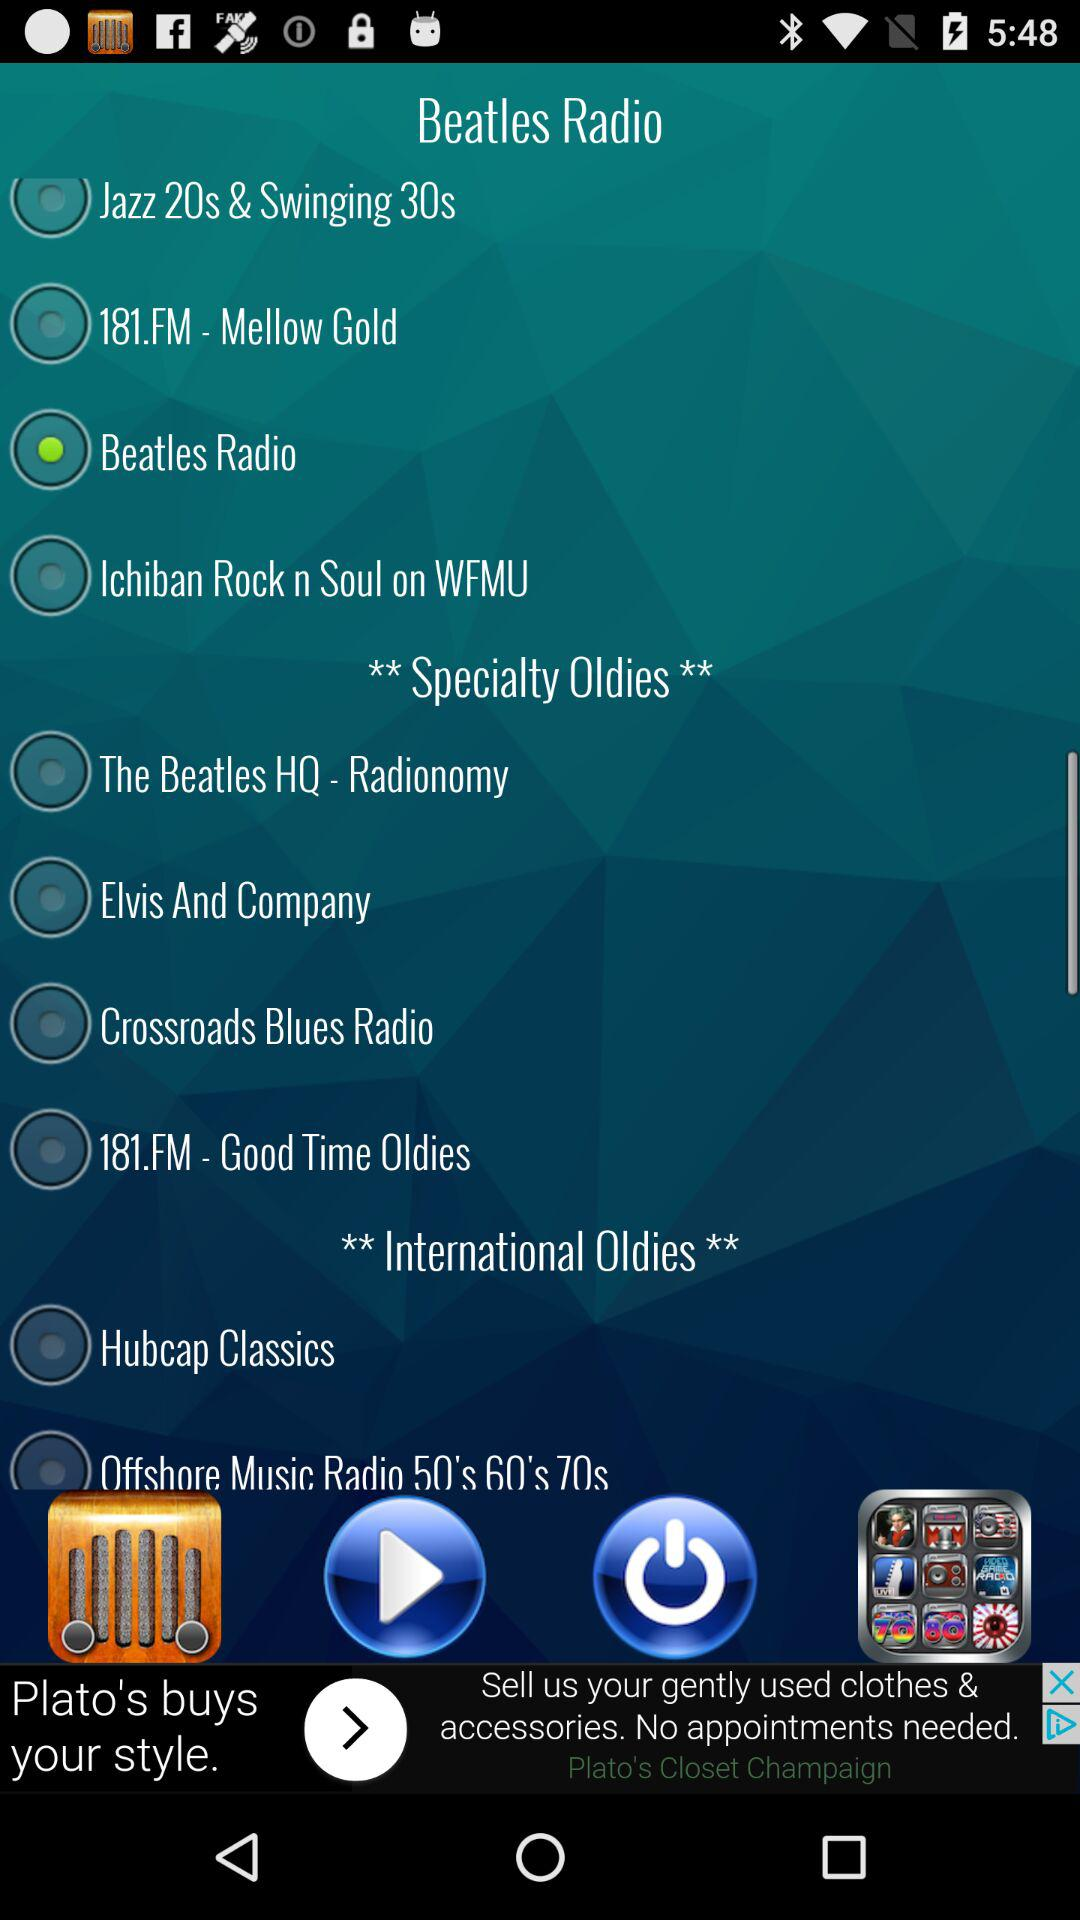Can you describe what the 'Beatles Radio' station might offer based on its name? Based on its name, 'Beatles Radio' likely offers music by The Beatles as well as possibly including genres and tracks from the same era or influenced by the band. It could be a great choice for fans of The Beatles or classic rock. 